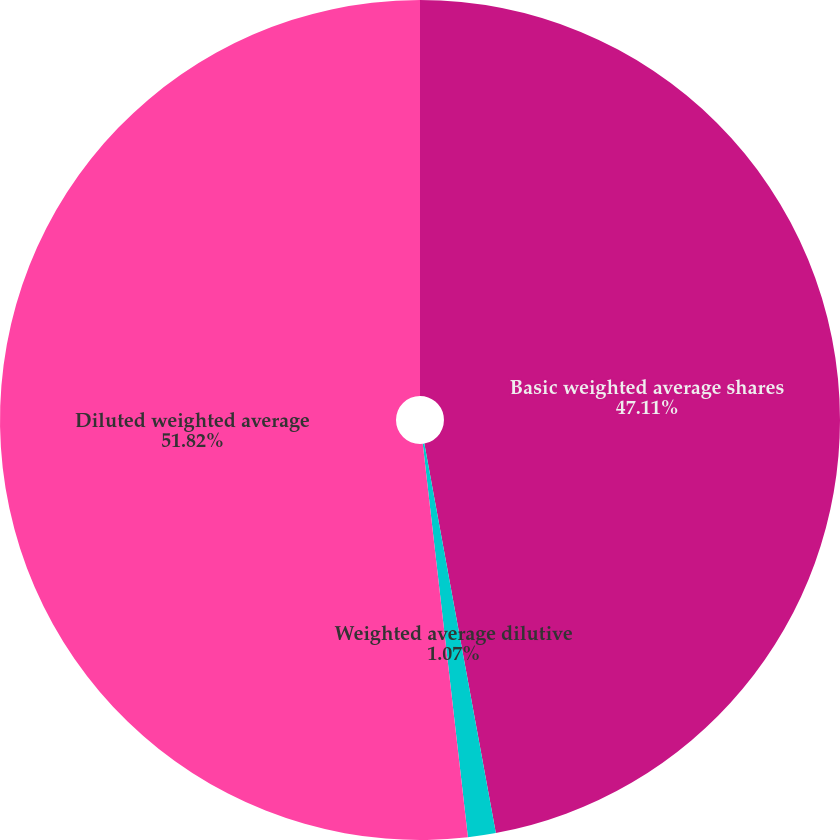<chart> <loc_0><loc_0><loc_500><loc_500><pie_chart><fcel>Basic weighted average shares<fcel>Weighted average dilutive<fcel>Diluted weighted average<nl><fcel>47.11%<fcel>1.07%<fcel>51.82%<nl></chart> 